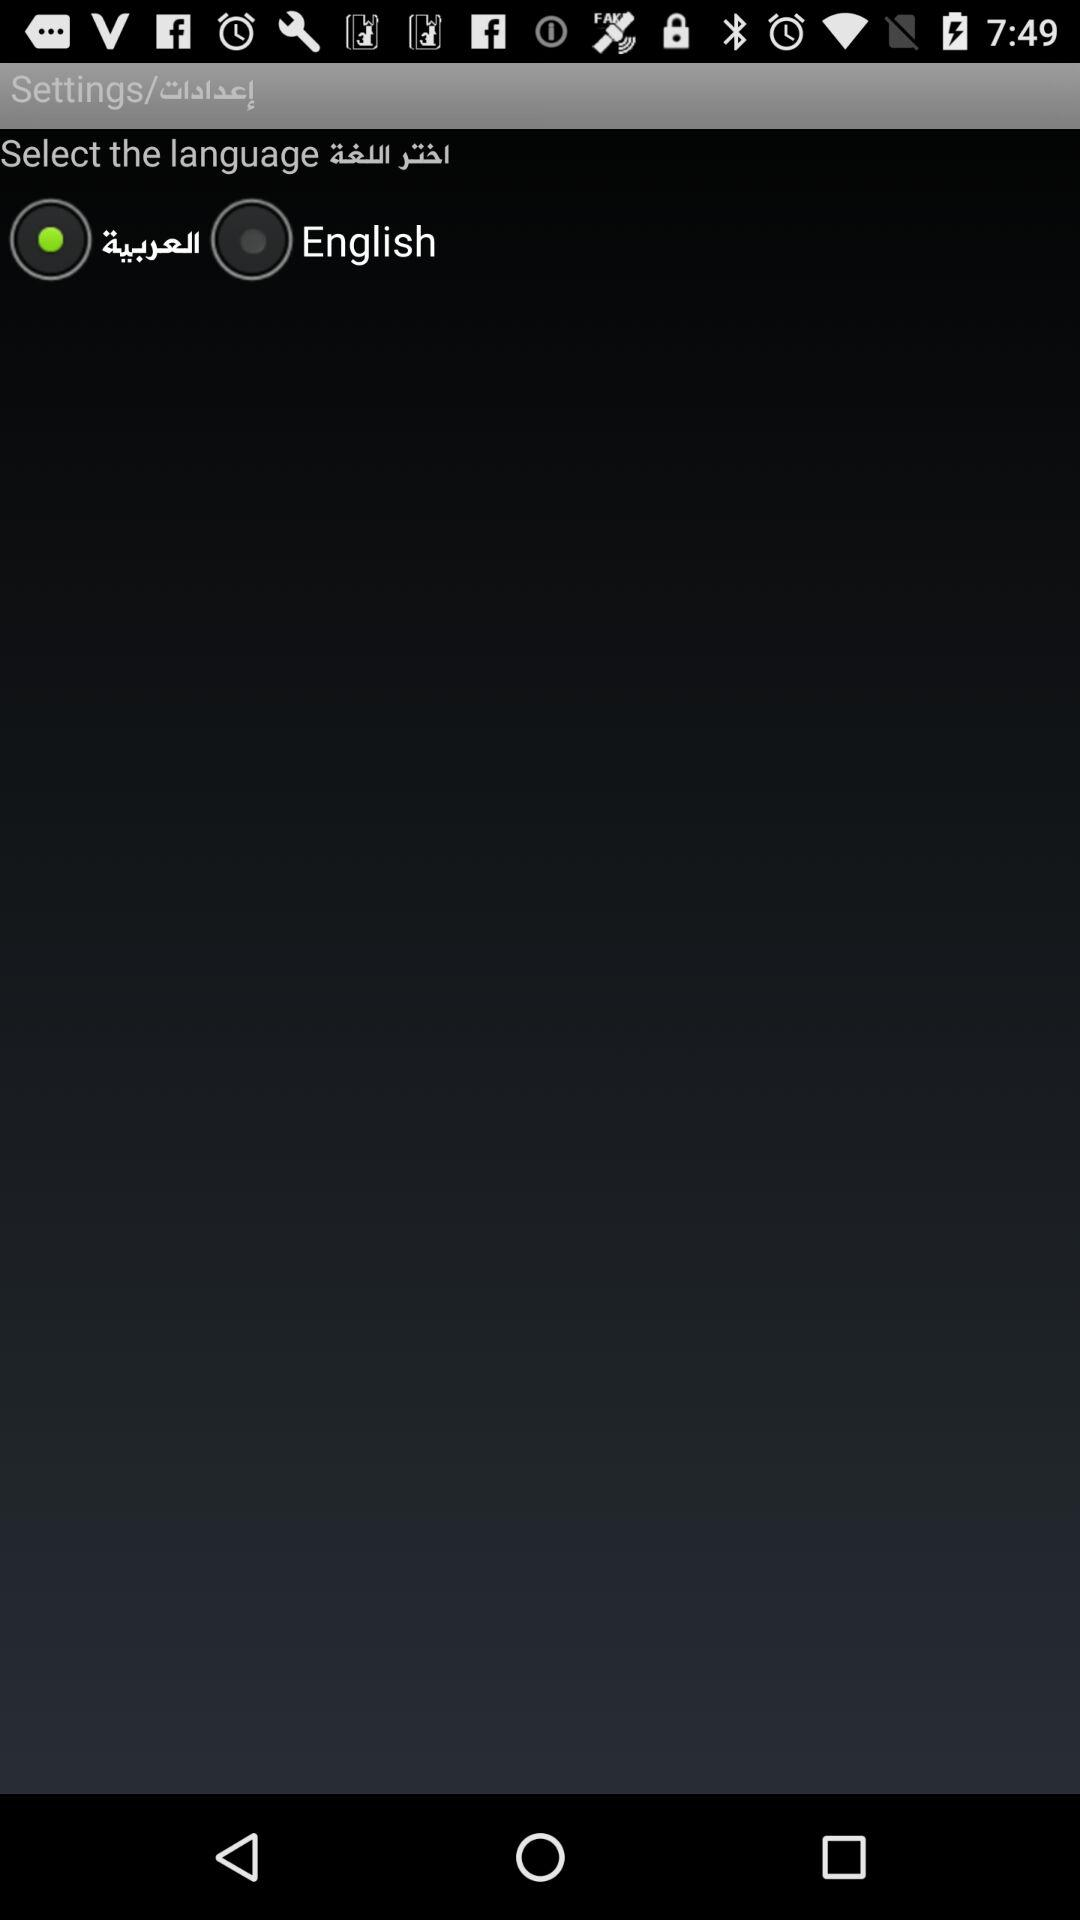How many languages are available to select?
Answer the question using a single word or phrase. 2 